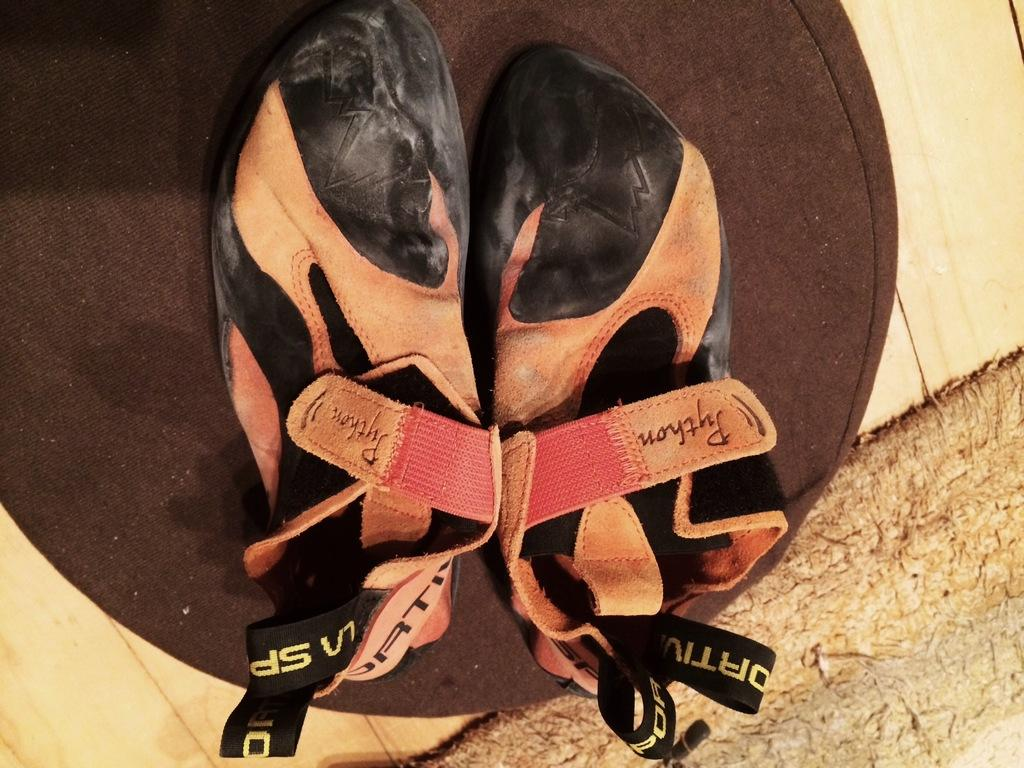What type of footwear is visible in the image? There are sandals in the image. Where are the sandals located? The sandals are placed on a surface. What type of disease is the rat carrying in the image? There is no rat or disease present in the image; it only features sandals placed on a surface. 